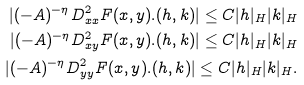<formula> <loc_0><loc_0><loc_500><loc_500>| ( - A ) ^ { - \eta } D _ { x x } ^ { 2 } F ( x , y ) . ( h , k ) | \leq C | h | _ { H } | k | _ { H } \\ | ( - A ) ^ { - \eta } D _ { x y } ^ { 2 } F ( x , y ) . ( h , k ) | \leq C | h | _ { H } | k | _ { H } \\ | ( - A ) ^ { - \eta } D _ { y y } ^ { 2 } F ( x , y ) . ( h , k ) | \leq C | h | _ { H } | k | _ { H } .</formula> 